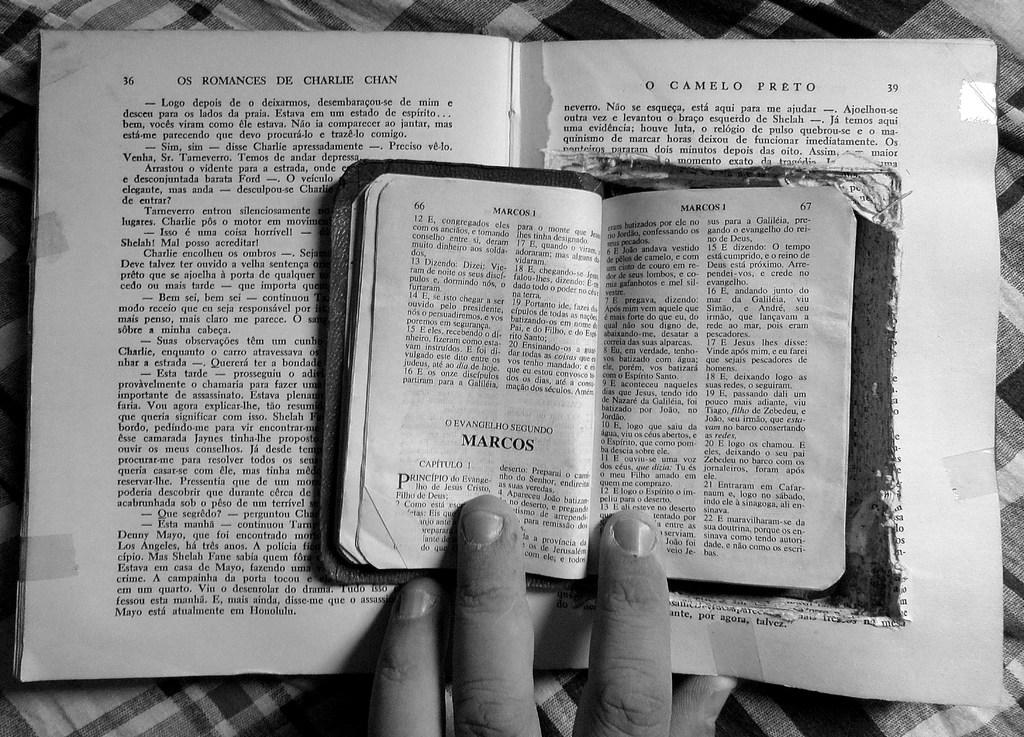<image>
Present a compact description of the photo's key features. Two open books, the larger of which has O camelo preto written on the right. 